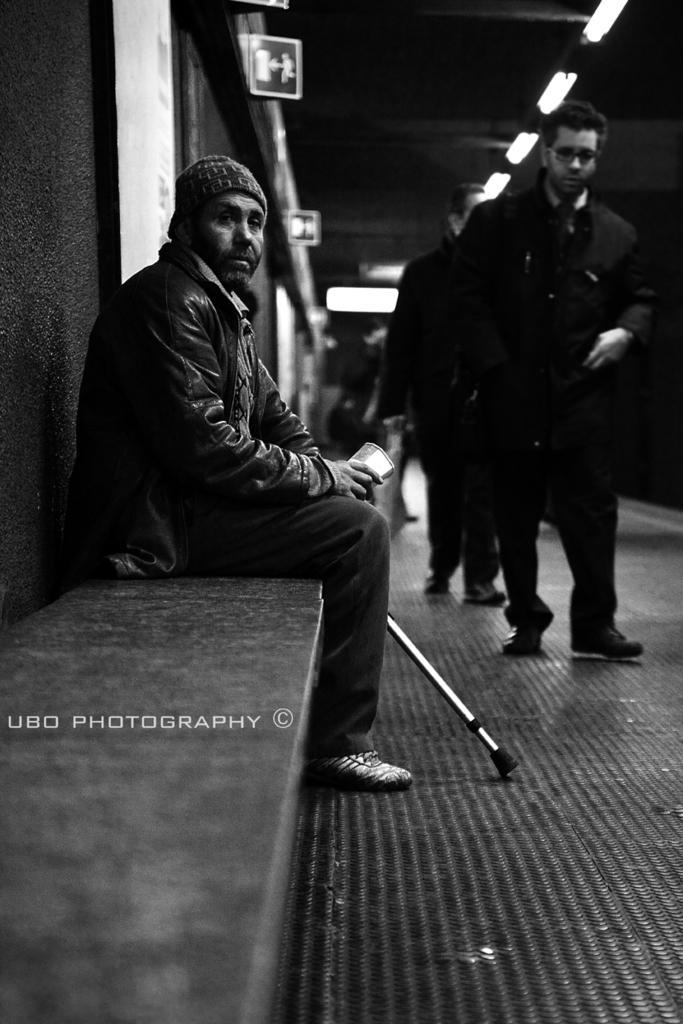Describe this image in one or two sentences. On the left we can see a person sitting on a bench and there is a wall also. On the right we can see people walking on the platform. In the background we can see boats, light and mostly it is blurred. 